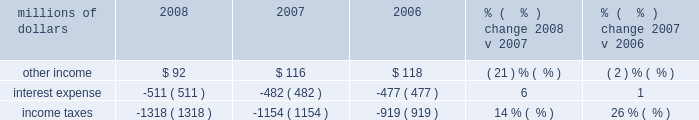Compared to 2007 .
We reduced personal injury expense by $ 80 million in 2007 as a result of fewer than expected claims and lower than expected average settlement costs .
In 2008 , we reduced personal injury expense and asbestos-related costs $ 82 million based on the results of updated personal injury actuarial studies and a reassessment of our potential liability for resolution of current and future asbestos claims .
In addition , environmental and toxic tort expenses were $ 7 million lower in 2008 compared to 2007 .
Other costs were lower in 2007 compared to 2006 driven primarily by a reduction in personal injury expense .
Actuarial studies completed during 2007 resulted in a reduction in personal injury expense of $ 80 million , which was partially offset by an adverse development with respect to one claim .
Settlement of insurance claims in 2007 related to hurricane rita , and higher equity income also drove expenses lower in 2007 versus 2006 .
Conversely , the year-over-year comparison was affected by the settlement of insurance claims totaling $ 23 million in 2006 related to the january 2005 west coast storm and a $ 9 million gain in 2006 from the sale of two company-owned airplanes .
Non-operating items millions of dollars 2008 2007 2006 % (  % ) change 2008 v 2007 % (  % ) change 2007 v 2006 .
Other income 2013 other income decreased in 2008 compared to 2007 due to lower gains from real estate sales and decreased returns on cash investments reflecting lower interest rates .
Higher rental and licensing income and lower interest expense on our sale of receivables program partially offset the decreases .
Lower net gains from non-operating asset sales ( primarily real estate ) drove the reduction in other income in 2007 .
Recognition of rental income in 2006 from the settlement of a rent dispute also contributed to the year-over-year decrease in other income .
Cash investment returns increased $ 21 million due to larger cash balances and higher interest rates .
Interest expense 2013 interest expense increased in 2008 versus 2007 due to a higher weighted-average debt level of $ 8.3 billion , compared to $ 7.3 billion in 2007 .
A lower effective interest rate of 6.1% ( 6.1 % ) in 2008 , compared to 6.6% ( 6.6 % ) in 2007 , partially offset the effects of the higher weighted-average debt level .
An increase in the weighted-average debt levels to $ 7.3 billion from $ 7.1 billion in 2006 generated higher interest expense in 2007 .
A lower effective interest rate of 6.6% ( 6.6 % ) in 2007 , compared to 6.7% ( 6.7 % ) in 2006 , partially offset the effects of the higher debt level .
Income taxes 2013 income taxes were higher in 2008 compared to 2007 , driven by higher pre-tax income .
Our effective tax rates were 36.1% ( 36.1 % ) and 38.4% ( 38.4 % ) in 2008 and 2007 , respectively .
The lower effective tax rate in 2008 resulted from several reductions in tax expense related to federal audits and state tax law changes .
In addition , the effective tax rate in 2007 was increased by illinois legislation that increased deferred tax expense in the third quarter of 2007 .
Income taxes were $ 235 million higher in 2007 compared to 2006 , due primarily to higher pre-tax income and the effect of new tax legislation in the state of illinois that changed how we determine the amount of our income subject to illinois tax .
The illinois legislation increased our deferred tax expense by $ 27 million in 2007 .
Our effective tax rates were 38.4% ( 38.4 % ) and 36.4% ( 36.4 % ) in 2007 and 2006 , respectively. .
What was the average other income? 
Computations: (((92 + 116) + 118) / 3)
Answer: 108.66667. 